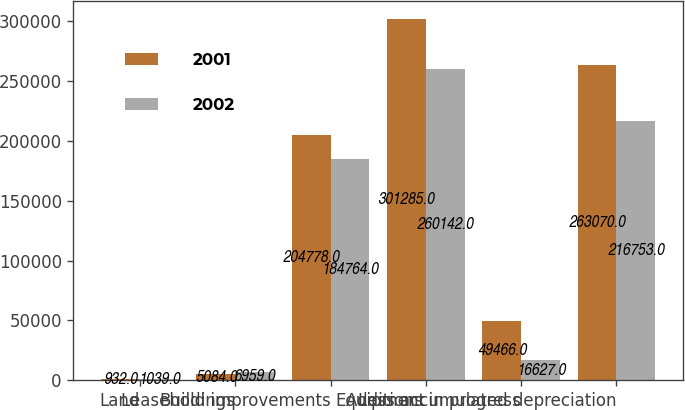Convert chart. <chart><loc_0><loc_0><loc_500><loc_500><stacked_bar_chart><ecel><fcel>Land<fcel>Buildings<fcel>Leasehold improvements<fcel>Equipment<fcel>Additions in progress<fcel>Less accumulated depreciation<nl><fcel>2001<fcel>932<fcel>5084<fcel>204778<fcel>301285<fcel>49466<fcel>263070<nl><fcel>2002<fcel>1039<fcel>6959<fcel>184764<fcel>260142<fcel>16627<fcel>216753<nl></chart> 